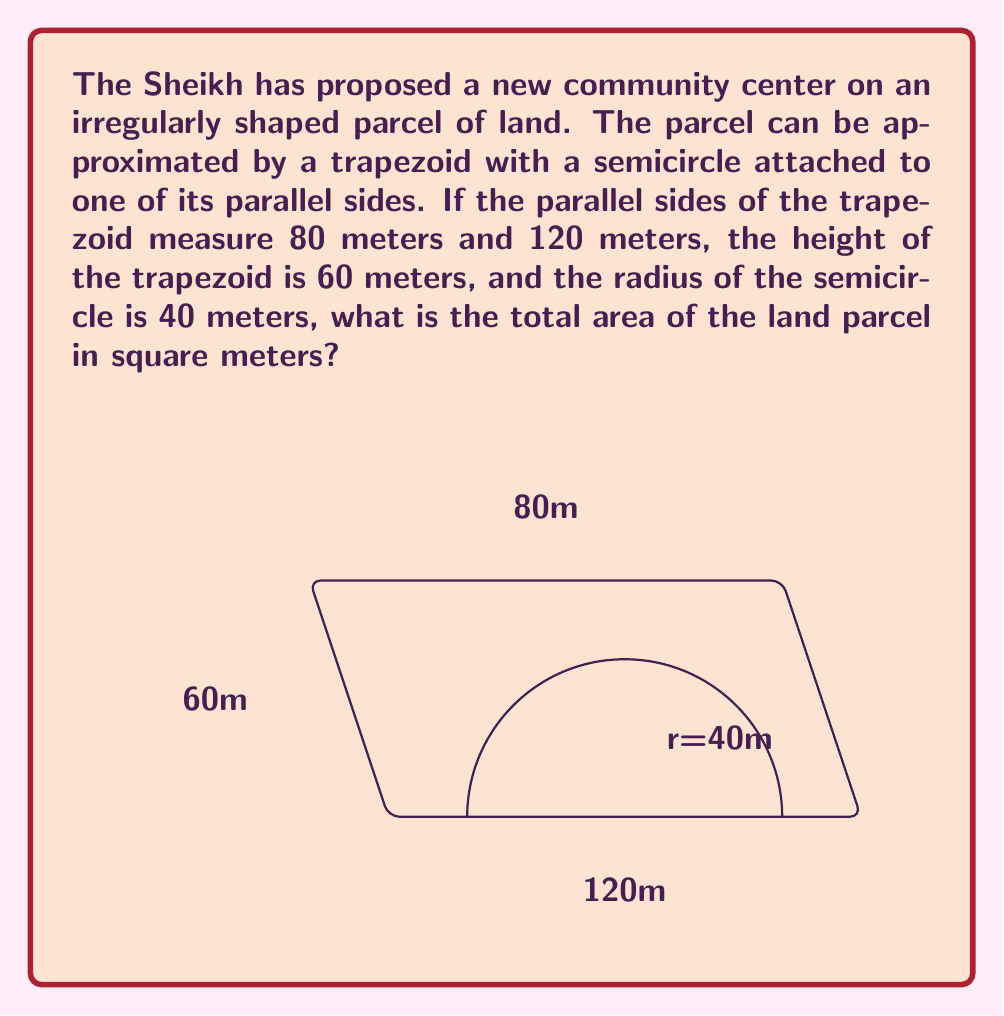Show me your answer to this math problem. To calculate the total area, we need to find the area of the trapezoid and the area of the semicircle, then add them together.

1. Area of the trapezoid:
   The formula for the area of a trapezoid is $A = \frac{1}{2}(b_1 + b_2)h$
   where $b_1$ and $b_2$ are the parallel sides and $h$ is the height.

   $$A_{trapezoid} = \frac{1}{2}(80 + 120) \times 60 = \frac{1}{2} \times 200 \times 60 = 6000 \text{ m}^2$$

2. Area of the semicircle:
   The formula for the area of a circle is $A = \pi r^2$
   For a semicircle, we take half of this.

   $$A_{semicircle} = \frac{1}{2} \pi r^2 = \frac{1}{2} \times \pi \times 40^2 = 800\pi \text{ m}^2$$

3. Total area:
   $$A_{total} = A_{trapezoid} + A_{semicircle} = 6000 + 800\pi \text{ m}^2$$

   To simplify, we can approximate $\pi$ to 3.14:
   $$A_{total} \approx 6000 + 800 \times 3.14 = 6000 + 2512 = 8512 \text{ m}^2$$
Answer: $8512 \text{ m}^2$ (approximate) 